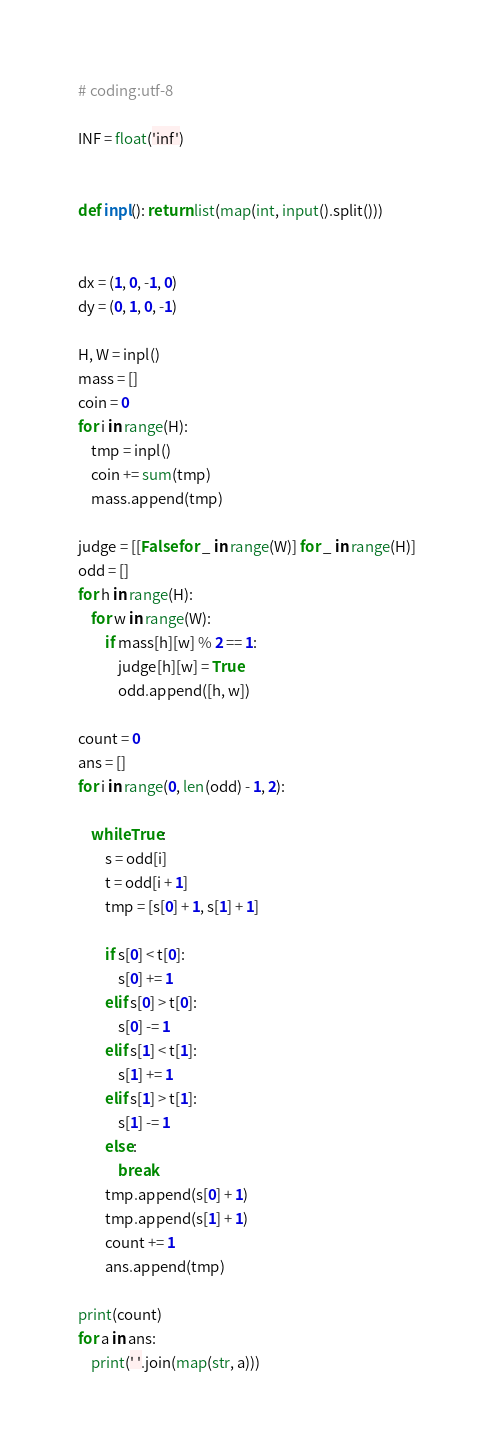Convert code to text. <code><loc_0><loc_0><loc_500><loc_500><_Python_># coding:utf-8

INF = float('inf')


def inpl(): return list(map(int, input().split()))


dx = (1, 0, -1, 0)
dy = (0, 1, 0, -1)

H, W = inpl()
mass = []
coin = 0
for i in range(H):
    tmp = inpl()
    coin += sum(tmp)
    mass.append(tmp)

judge = [[False for _ in range(W)] for _ in range(H)]
odd = []
for h in range(H):
    for w in range(W):
        if mass[h][w] % 2 == 1:
            judge[h][w] = True
            odd.append([h, w])

count = 0
ans = []
for i in range(0, len(odd) - 1, 2):

    while True:
        s = odd[i]
        t = odd[i + 1]
        tmp = [s[0] + 1, s[1] + 1]

        if s[0] < t[0]:
            s[0] += 1
        elif s[0] > t[0]:
            s[0] -= 1
        elif s[1] < t[1]:
            s[1] += 1
        elif s[1] > t[1]:
            s[1] -= 1
        else:
            break
        tmp.append(s[0] + 1)
        tmp.append(s[1] + 1)
        count += 1
        ans.append(tmp)

print(count)
for a in ans:
    print(' '.join(map(str, a)))
</code> 